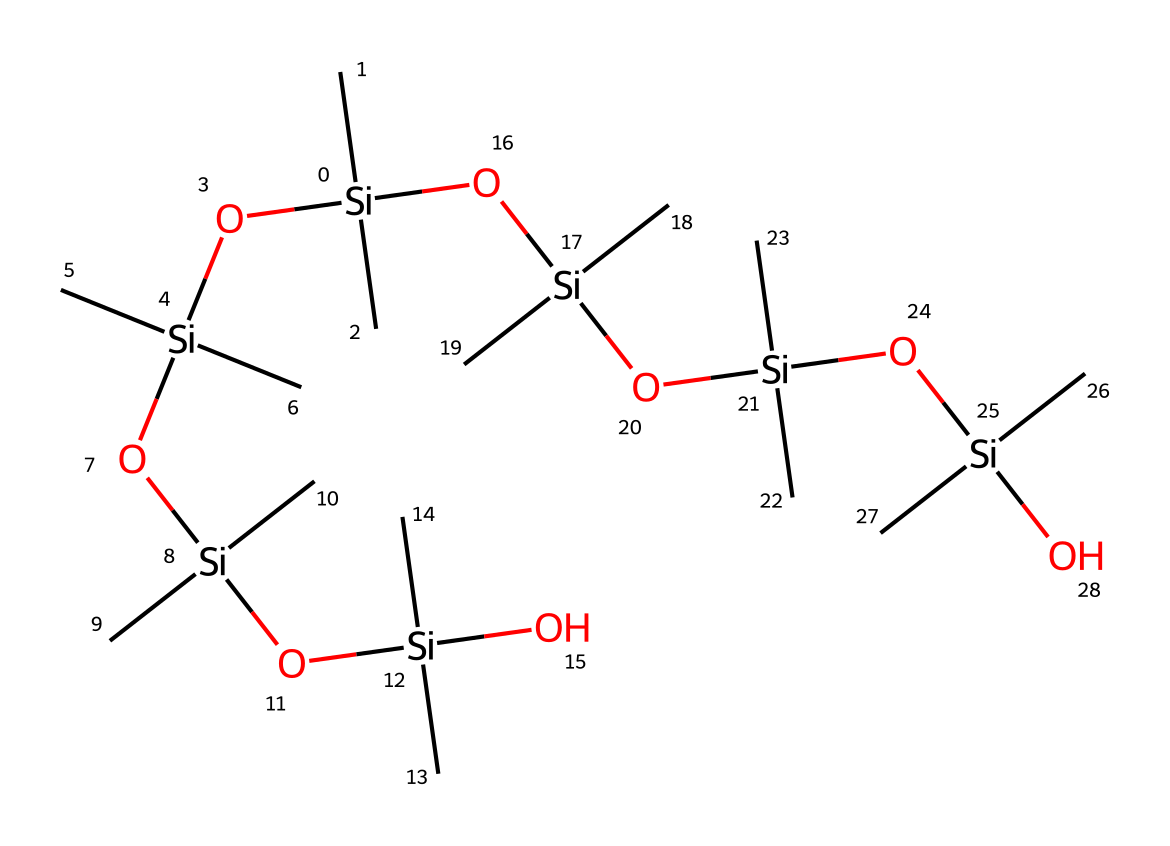What is the central atom in this structure? The structure prominently features silicon as the backbone of the molecule, with multiple silicon atoms connected to oxygen and carbon.
Answer: silicon How many silicon atoms are present in this chemical structure? By examining the SMILES representation, each '[Si]' denotes a silicon atom. Counting gives us a total of 8 silicon atoms in this structure.
Answer: 8 What functional group is indicative of this being a silicone-based lubricant? The presence of the siloxane bonds (Si-O) in the structure indicates that this compound functions as a silicone lubricant.
Answer: siloxane What is the total number of carbon atoms in this chemical? Each '(C)' denotes a carbon atom. Given there are 12 occurrences of '(C)', we conclude that there are 12 carbon atoms.
Answer: 12 Which elements are present in this silicone-based lubricant? The structure contains silicon, carbon, and oxygen atoms, which are indicated by '[Si]', '(C)', and 'O' in the SMILES representation.
Answer: silicon, carbon, oxygen What type of bonding is predominantly found in silicone-based lubricants? The structure exhibits covalent bonding, primarily between silicon and oxygen, which is characteristic of siloxanes.
Answer: covalent What characteristic of this chemical might contribute to its lubricating properties? The flexible siloxane chain allows for a low coefficient of friction, enhancing lubrication due to its ability to easily slide past surfaces.
Answer: low friction 